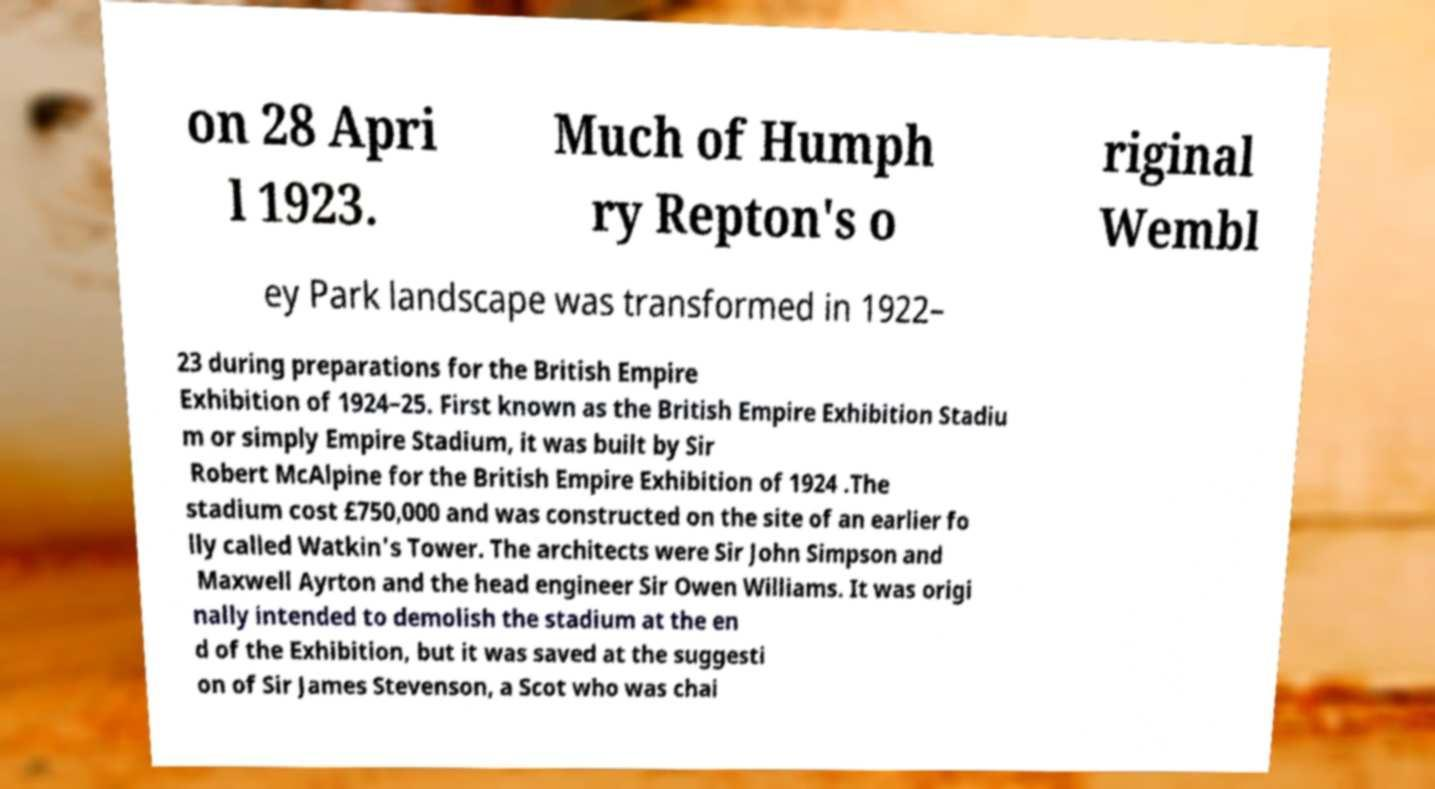Could you assist in decoding the text presented in this image and type it out clearly? on 28 Apri l 1923. Much of Humph ry Repton's o riginal Wembl ey Park landscape was transformed in 1922– 23 during preparations for the British Empire Exhibition of 1924–25. First known as the British Empire Exhibition Stadiu m or simply Empire Stadium, it was built by Sir Robert McAlpine for the British Empire Exhibition of 1924 .The stadium cost £750,000 and was constructed on the site of an earlier fo lly called Watkin's Tower. The architects were Sir John Simpson and Maxwell Ayrton and the head engineer Sir Owen Williams. It was origi nally intended to demolish the stadium at the en d of the Exhibition, but it was saved at the suggesti on of Sir James Stevenson, a Scot who was chai 